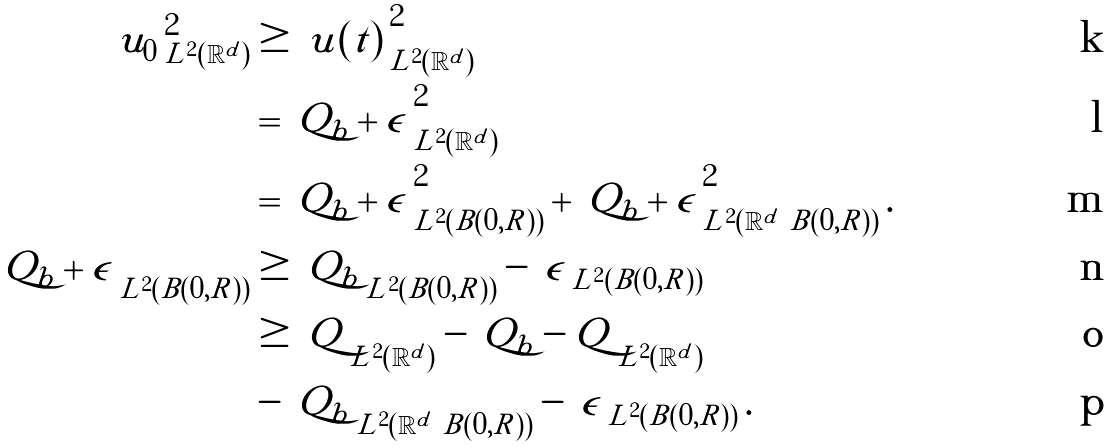Convert formula to latex. <formula><loc_0><loc_0><loc_500><loc_500>\left \| u _ { 0 } \right \| _ { L ^ { 2 } ( \mathbb { R } ^ { d } ) } ^ { 2 } & \geq \left \| u ( t ) \right \| _ { L ^ { 2 } ( \mathbb { R } ^ { d } ) } ^ { 2 } \\ & = \left \| Q _ { b } + \epsilon \right \| _ { L ^ { 2 } ( \mathbb { R } ^ { d } ) } ^ { 2 } \\ & = \left \| Q _ { b } + \epsilon \right \| _ { L ^ { 2 } ( B ( 0 , R ) ) } ^ { 2 } + \left \| Q _ { b } + \epsilon \right \| _ { L ^ { 2 } ( \mathbb { R } ^ { d } \ B ( 0 , R ) ) } ^ { 2 } . \\ \left \| Q _ { b } + \epsilon \right \| _ { L ^ { 2 } ( B ( 0 , R ) ) } & \geq \left \| Q _ { b } \right \| _ { L ^ { 2 } ( B ( 0 , R ) ) } - \left \| \epsilon \right \| _ { L ^ { 2 } ( B ( 0 , R ) ) } \\ & \geq \left \| Q \right \| _ { L ^ { 2 } ( \mathbb { R } ^ { d } ) } - \left \| Q _ { b } - Q \right \| _ { L ^ { 2 } ( \mathbb { R } ^ { d } ) } \\ & - \left \| Q _ { b } \right \| _ { L ^ { 2 } ( \mathbb { R } ^ { d } \ B ( 0 , R ) ) } - \left \| \epsilon \right \| _ { L ^ { 2 } ( B ( 0 , R ) ) } .</formula> 